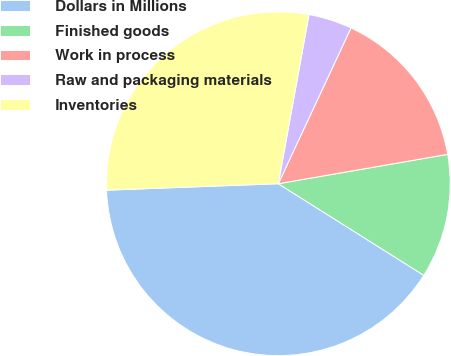Convert chart to OTSL. <chart><loc_0><loc_0><loc_500><loc_500><pie_chart><fcel>Dollars in Millions<fcel>Finished goods<fcel>Work in process<fcel>Raw and packaging materials<fcel>Inventories<nl><fcel>40.46%<fcel>11.68%<fcel>15.32%<fcel>4.09%<fcel>28.46%<nl></chart> 